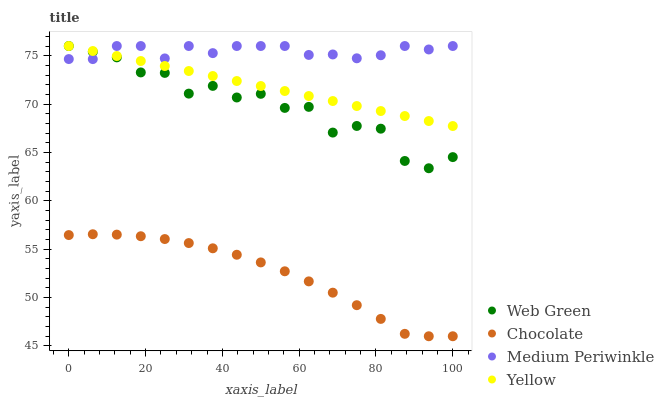Does Chocolate have the minimum area under the curve?
Answer yes or no. Yes. Does Medium Periwinkle have the maximum area under the curve?
Answer yes or no. Yes. Does Yellow have the minimum area under the curve?
Answer yes or no. No. Does Yellow have the maximum area under the curve?
Answer yes or no. No. Is Yellow the smoothest?
Answer yes or no. Yes. Is Web Green the roughest?
Answer yes or no. Yes. Is Web Green the smoothest?
Answer yes or no. No. Is Yellow the roughest?
Answer yes or no. No. Does Chocolate have the lowest value?
Answer yes or no. Yes. Does Yellow have the lowest value?
Answer yes or no. No. Does Web Green have the highest value?
Answer yes or no. Yes. Does Chocolate have the highest value?
Answer yes or no. No. Is Chocolate less than Medium Periwinkle?
Answer yes or no. Yes. Is Yellow greater than Chocolate?
Answer yes or no. Yes. Does Web Green intersect Medium Periwinkle?
Answer yes or no. Yes. Is Web Green less than Medium Periwinkle?
Answer yes or no. No. Is Web Green greater than Medium Periwinkle?
Answer yes or no. No. Does Chocolate intersect Medium Periwinkle?
Answer yes or no. No. 